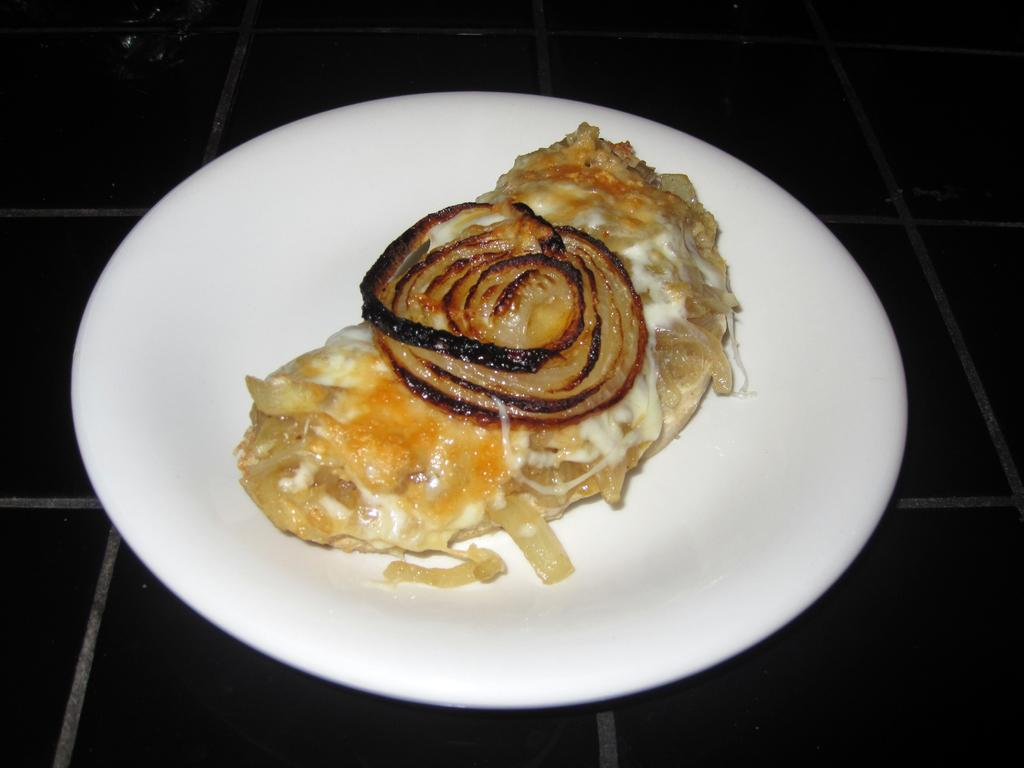What is present on the plate in the image? There are food items in a plate. Where is the plate located in the image? The plate is placed on the floor. What type of crib can be seen in the background of the image? There is no crib present in the image; it only features a plate with food items placed on the floor. 